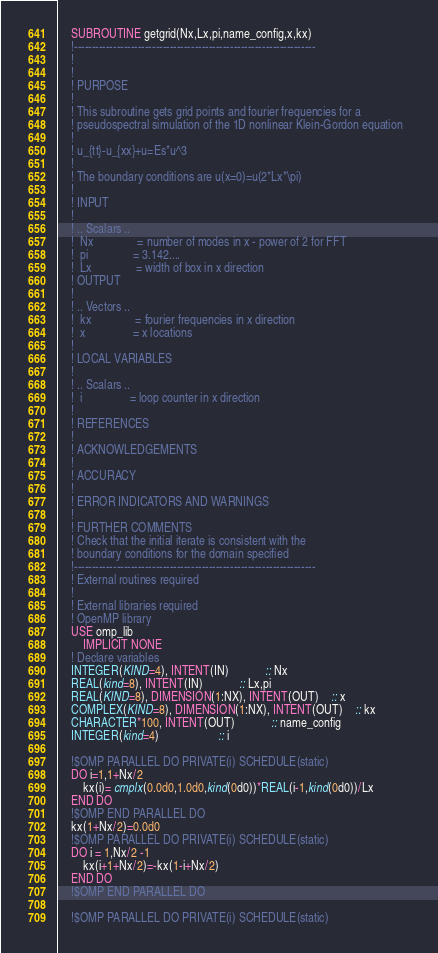<code> <loc_0><loc_0><loc_500><loc_500><_FORTRAN_>	SUBROUTINE getgrid(Nx,Lx,pi,name_config,x,kx)
	!--------------------------------------------------------------------
	!
	!
	! PURPOSE
	!
	! This subroutine gets grid points and fourier frequencies for a
	! pseudospectral simulation of the 1D nonlinear Klein-Gordon equation
	!
	! u_{tt}-u_{xx}+u=Es*u^3
	!
	! The boundary conditions are u(x=0)=u(2*Lx*\pi) 
	!
	! INPUT
	!
	! .. Scalars ..
	!  Nx				= number of modes in x - power of 2 for FFT
	!  pi				= 3.142....
	!  Lx				= width of box in x direction
	! OUTPUT
	!
	! .. Vectors ..
	!  kx				= fourier frequencies in x direction
	!  x				= x locations
	!
	! LOCAL VARIABLES
	!
	! .. Scalars ..
	!  i				= loop counter in x direction
	!
	! REFERENCES
	!
	! ACKNOWLEDGEMENTS
	!
	! ACCURACY
	!		
	! ERROR INDICATORS AND WARNINGS
	!
	! FURTHER COMMENTS
	! Check that the initial iterate is consistent with the 
	! boundary conditions for the domain specified
	!--------------------------------------------------------------------
	! External routines required
	! 
	! External libraries required
	! OpenMP library
	USE omp_lib		 	   
        IMPLICIT NONE
	! Declare variables
	INTEGER(KIND=4), INTENT(IN)			:: Nx
	REAL(kind=8), INTENT(IN)			:: Lx,pi
	REAL(KIND=8), DIMENSION(1:NX), INTENT(OUT) 	:: x
	COMPLEX(KIND=8), DIMENSION(1:NX), INTENT(OUT)	:: kx
	CHARACTER*100, INTENT(OUT)			:: name_config
	INTEGER(kind=4)					:: i
		
	!$OMP PARALLEL DO PRIVATE(i) SCHEDULE(static)
	DO i=1,1+Nx/2
		kx(i)= cmplx(0.0d0,1.0d0,kind(0d0))*REAL(i-1,kind(0d0))/Lx  			
	END DO
	!$OMP END PARALLEL DO
	kx(1+Nx/2)=0.0d0
	!$OMP PARALLEL DO PRIVATE(i) SCHEDULE(static)
	DO i = 1,Nx/2 -1
		kx(i+1+Nx/2)=-kx(1-i+Nx/2)
	END DO
	!$OMP END PARALLEL DO
		
	!$OMP PARALLEL DO PRIVATE(i) SCHEDULE(static)</code> 